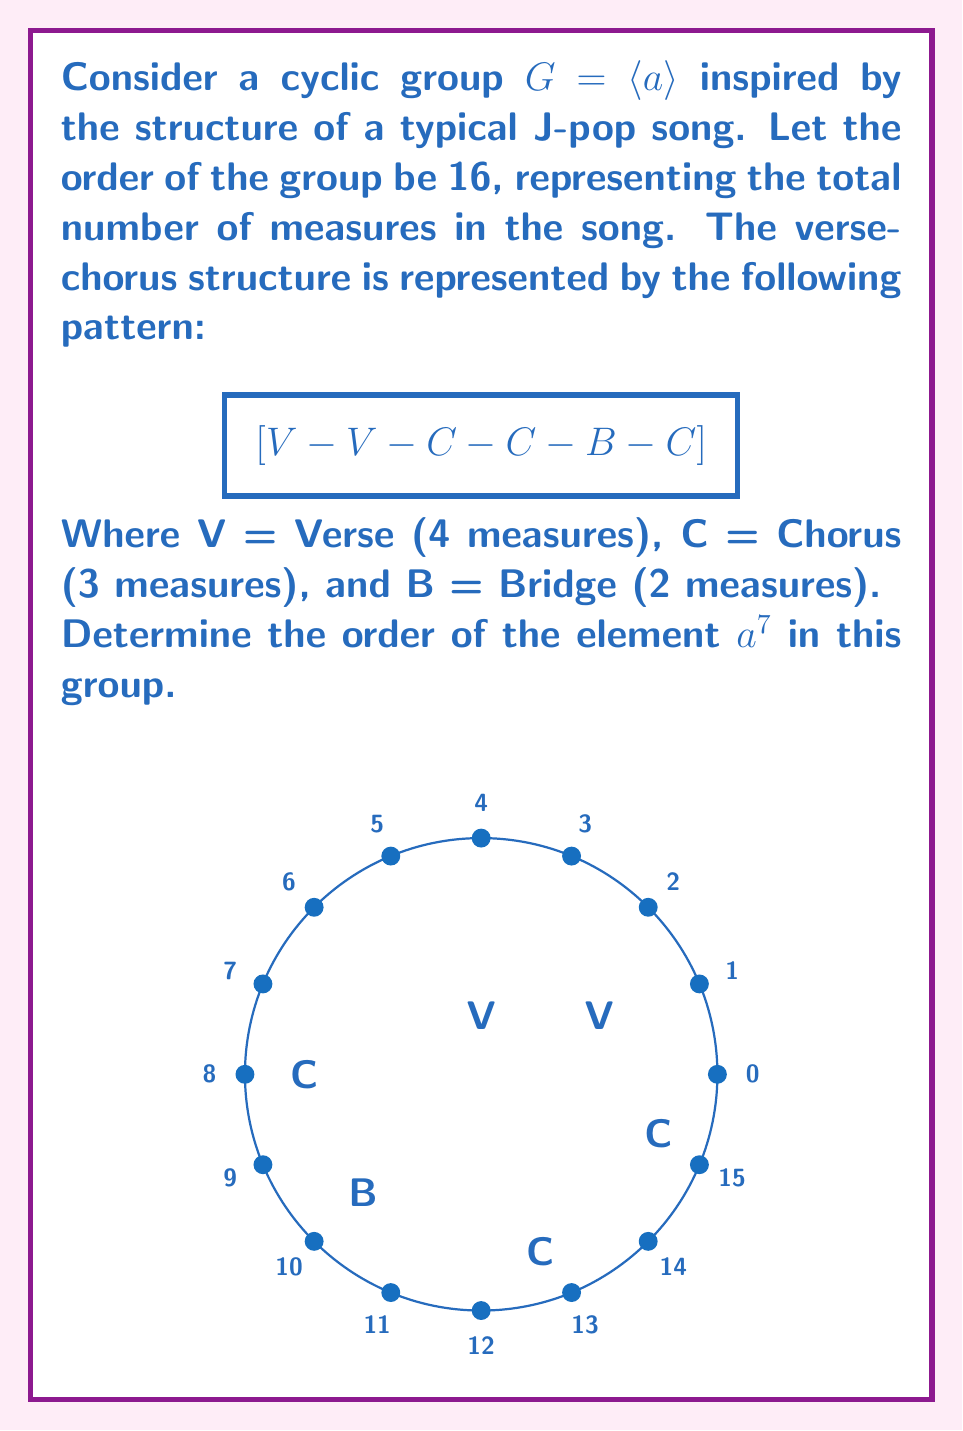Teach me how to tackle this problem. Let's approach this step-by-step:

1) In a cyclic group of order 16, we have $|G| = 16$.

2) To find the order of $a^7$, we need to find the smallest positive integer $k$ such that $(a^7)^k = e$ (the identity element).

3) This is equivalent to finding the smallest positive $k$ such that $7k \equiv 0 \pmod{16}$.

4) We can use the concept of greatest common divisor (gcd) here:
   
   $\text{ord}(a^7) = \frac{|G|}{\gcd(7,16)} = \frac{16}{\gcd(7,16)}$

5) Let's calculate $\gcd(7,16)$:
   
   $16 = 2 \cdot 7 + 2$
   $7 = 3 \cdot 2 + 1$
   $2 = 2 \cdot 1 + 0$

   Therefore, $\gcd(7,16) = 1$

6) Now we can calculate the order:

   $\text{ord}(a^7) = \frac{16}{1} = 16$

Thus, the order of $a^7$ is 16, which means it generates the entire group. This is analogous to how the 7th measure in our J-pop song structure (the start of the second chorus) can be seen as a key point that leads back to the beginning of the song structure.
Answer: 16 